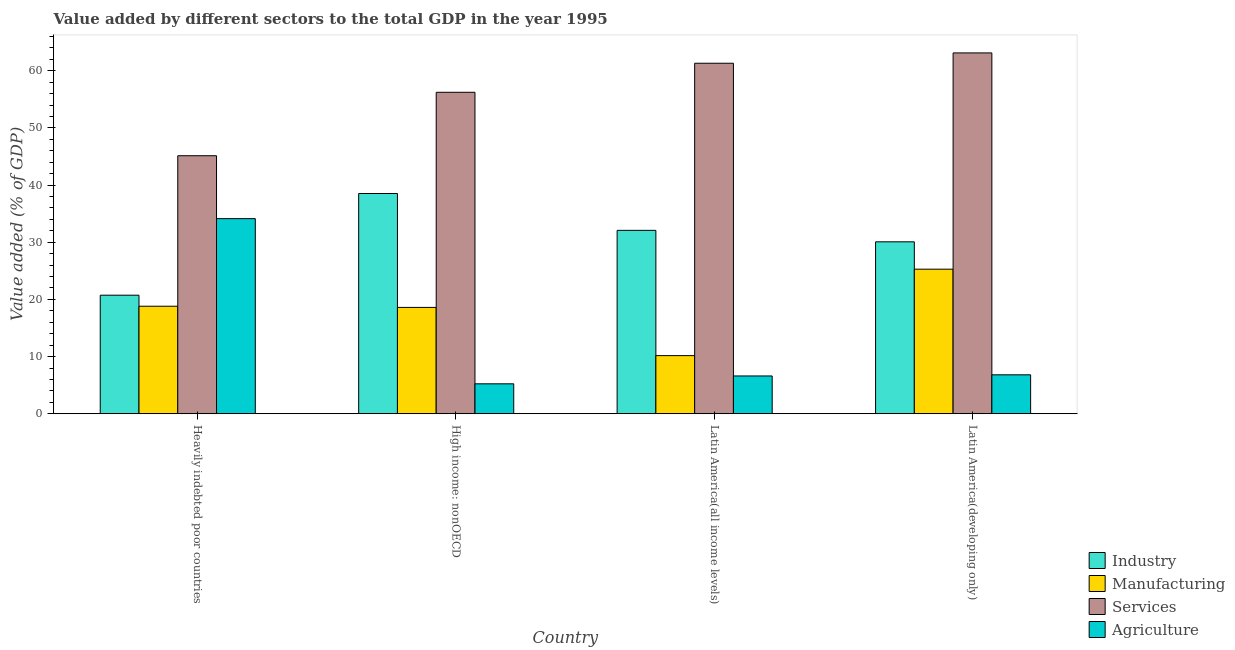How many groups of bars are there?
Provide a succinct answer. 4. Are the number of bars per tick equal to the number of legend labels?
Make the answer very short. Yes. How many bars are there on the 1st tick from the left?
Ensure brevity in your answer.  4. How many bars are there on the 4th tick from the right?
Your response must be concise. 4. What is the label of the 2nd group of bars from the left?
Your answer should be compact. High income: nonOECD. In how many cases, is the number of bars for a given country not equal to the number of legend labels?
Give a very brief answer. 0. What is the value added by manufacturing sector in Latin America(developing only)?
Offer a very short reply. 25.29. Across all countries, what is the maximum value added by services sector?
Offer a very short reply. 63.12. Across all countries, what is the minimum value added by services sector?
Give a very brief answer. 45.13. In which country was the value added by manufacturing sector maximum?
Make the answer very short. Latin America(developing only). In which country was the value added by agricultural sector minimum?
Ensure brevity in your answer.  High income: nonOECD. What is the total value added by manufacturing sector in the graph?
Ensure brevity in your answer.  72.86. What is the difference between the value added by industrial sector in Heavily indebted poor countries and that in Latin America(all income levels)?
Your answer should be very brief. -11.34. What is the difference between the value added by agricultural sector in Latin America(developing only) and the value added by services sector in Heavily indebted poor countries?
Offer a very short reply. -38.33. What is the average value added by services sector per country?
Provide a succinct answer. 56.45. What is the difference between the value added by industrial sector and value added by agricultural sector in Heavily indebted poor countries?
Provide a succinct answer. -13.39. What is the ratio of the value added by industrial sector in High income: nonOECD to that in Latin America(developing only)?
Provide a short and direct response. 1.28. Is the value added by manufacturing sector in Heavily indebted poor countries less than that in Latin America(all income levels)?
Your response must be concise. No. Is the difference between the value added by services sector in High income: nonOECD and Latin America(developing only) greater than the difference between the value added by industrial sector in High income: nonOECD and Latin America(developing only)?
Ensure brevity in your answer.  No. What is the difference between the highest and the second highest value added by services sector?
Offer a terse response. 1.81. What is the difference between the highest and the lowest value added by agricultural sector?
Provide a short and direct response. 28.9. In how many countries, is the value added by agricultural sector greater than the average value added by agricultural sector taken over all countries?
Offer a very short reply. 1. Is the sum of the value added by services sector in Heavily indebted poor countries and High income: nonOECD greater than the maximum value added by manufacturing sector across all countries?
Ensure brevity in your answer.  Yes. What does the 2nd bar from the left in High income: nonOECD represents?
Provide a succinct answer. Manufacturing. What does the 1st bar from the right in High income: nonOECD represents?
Your response must be concise. Agriculture. Are all the bars in the graph horizontal?
Provide a succinct answer. No. How many countries are there in the graph?
Your answer should be very brief. 4. What is the difference between two consecutive major ticks on the Y-axis?
Offer a very short reply. 10. Are the values on the major ticks of Y-axis written in scientific E-notation?
Ensure brevity in your answer.  No. Does the graph contain any zero values?
Your answer should be compact. No. What is the title of the graph?
Give a very brief answer. Value added by different sectors to the total GDP in the year 1995. What is the label or title of the X-axis?
Keep it short and to the point. Country. What is the label or title of the Y-axis?
Keep it short and to the point. Value added (% of GDP). What is the Value added (% of GDP) of Industry in Heavily indebted poor countries?
Your response must be concise. 20.74. What is the Value added (% of GDP) of Manufacturing in Heavily indebted poor countries?
Your response must be concise. 18.81. What is the Value added (% of GDP) in Services in Heavily indebted poor countries?
Offer a very short reply. 45.13. What is the Value added (% of GDP) in Agriculture in Heavily indebted poor countries?
Your response must be concise. 34.13. What is the Value added (% of GDP) in Industry in High income: nonOECD?
Provide a succinct answer. 38.53. What is the Value added (% of GDP) in Manufacturing in High income: nonOECD?
Your answer should be very brief. 18.6. What is the Value added (% of GDP) in Services in High income: nonOECD?
Ensure brevity in your answer.  56.23. What is the Value added (% of GDP) of Agriculture in High income: nonOECD?
Offer a terse response. 5.23. What is the Value added (% of GDP) of Industry in Latin America(all income levels)?
Keep it short and to the point. 32.08. What is the Value added (% of GDP) of Manufacturing in Latin America(all income levels)?
Make the answer very short. 10.17. What is the Value added (% of GDP) in Services in Latin America(all income levels)?
Your answer should be compact. 61.31. What is the Value added (% of GDP) in Agriculture in Latin America(all income levels)?
Provide a succinct answer. 6.61. What is the Value added (% of GDP) of Industry in Latin America(developing only)?
Your answer should be compact. 30.07. What is the Value added (% of GDP) in Manufacturing in Latin America(developing only)?
Your response must be concise. 25.29. What is the Value added (% of GDP) in Services in Latin America(developing only)?
Offer a very short reply. 63.12. What is the Value added (% of GDP) of Agriculture in Latin America(developing only)?
Offer a terse response. 6.81. Across all countries, what is the maximum Value added (% of GDP) in Industry?
Keep it short and to the point. 38.53. Across all countries, what is the maximum Value added (% of GDP) of Manufacturing?
Keep it short and to the point. 25.29. Across all countries, what is the maximum Value added (% of GDP) of Services?
Your response must be concise. 63.12. Across all countries, what is the maximum Value added (% of GDP) of Agriculture?
Your answer should be very brief. 34.13. Across all countries, what is the minimum Value added (% of GDP) of Industry?
Provide a succinct answer. 20.74. Across all countries, what is the minimum Value added (% of GDP) in Manufacturing?
Offer a very short reply. 10.17. Across all countries, what is the minimum Value added (% of GDP) of Services?
Provide a succinct answer. 45.13. Across all countries, what is the minimum Value added (% of GDP) in Agriculture?
Your answer should be very brief. 5.23. What is the total Value added (% of GDP) of Industry in the graph?
Give a very brief answer. 121.42. What is the total Value added (% of GDP) of Manufacturing in the graph?
Make the answer very short. 72.86. What is the total Value added (% of GDP) in Services in the graph?
Keep it short and to the point. 225.8. What is the total Value added (% of GDP) of Agriculture in the graph?
Keep it short and to the point. 52.78. What is the difference between the Value added (% of GDP) of Industry in Heavily indebted poor countries and that in High income: nonOECD?
Your response must be concise. -17.79. What is the difference between the Value added (% of GDP) of Manufacturing in Heavily indebted poor countries and that in High income: nonOECD?
Ensure brevity in your answer.  0.21. What is the difference between the Value added (% of GDP) in Services in Heavily indebted poor countries and that in High income: nonOECD?
Provide a succinct answer. -11.1. What is the difference between the Value added (% of GDP) in Agriculture in Heavily indebted poor countries and that in High income: nonOECD?
Your answer should be compact. 28.9. What is the difference between the Value added (% of GDP) in Industry in Heavily indebted poor countries and that in Latin America(all income levels)?
Your response must be concise. -11.34. What is the difference between the Value added (% of GDP) of Manufacturing in Heavily indebted poor countries and that in Latin America(all income levels)?
Provide a succinct answer. 8.64. What is the difference between the Value added (% of GDP) of Services in Heavily indebted poor countries and that in Latin America(all income levels)?
Your answer should be very brief. -16.18. What is the difference between the Value added (% of GDP) of Agriculture in Heavily indebted poor countries and that in Latin America(all income levels)?
Your response must be concise. 27.52. What is the difference between the Value added (% of GDP) in Industry in Heavily indebted poor countries and that in Latin America(developing only)?
Provide a succinct answer. -9.34. What is the difference between the Value added (% of GDP) of Manufacturing in Heavily indebted poor countries and that in Latin America(developing only)?
Your answer should be very brief. -6.48. What is the difference between the Value added (% of GDP) of Services in Heavily indebted poor countries and that in Latin America(developing only)?
Provide a succinct answer. -17.99. What is the difference between the Value added (% of GDP) of Agriculture in Heavily indebted poor countries and that in Latin America(developing only)?
Ensure brevity in your answer.  27.32. What is the difference between the Value added (% of GDP) of Industry in High income: nonOECD and that in Latin America(all income levels)?
Your answer should be compact. 6.45. What is the difference between the Value added (% of GDP) in Manufacturing in High income: nonOECD and that in Latin America(all income levels)?
Offer a terse response. 8.43. What is the difference between the Value added (% of GDP) in Services in High income: nonOECD and that in Latin America(all income levels)?
Provide a short and direct response. -5.08. What is the difference between the Value added (% of GDP) in Agriculture in High income: nonOECD and that in Latin America(all income levels)?
Keep it short and to the point. -1.37. What is the difference between the Value added (% of GDP) in Industry in High income: nonOECD and that in Latin America(developing only)?
Your answer should be very brief. 8.46. What is the difference between the Value added (% of GDP) of Manufacturing in High income: nonOECD and that in Latin America(developing only)?
Provide a succinct answer. -6.69. What is the difference between the Value added (% of GDP) of Services in High income: nonOECD and that in Latin America(developing only)?
Ensure brevity in your answer.  -6.89. What is the difference between the Value added (% of GDP) of Agriculture in High income: nonOECD and that in Latin America(developing only)?
Give a very brief answer. -1.57. What is the difference between the Value added (% of GDP) in Industry in Latin America(all income levels) and that in Latin America(developing only)?
Your answer should be very brief. 2.01. What is the difference between the Value added (% of GDP) of Manufacturing in Latin America(all income levels) and that in Latin America(developing only)?
Your answer should be very brief. -15.12. What is the difference between the Value added (% of GDP) of Services in Latin America(all income levels) and that in Latin America(developing only)?
Provide a succinct answer. -1.81. What is the difference between the Value added (% of GDP) in Agriculture in Latin America(all income levels) and that in Latin America(developing only)?
Give a very brief answer. -0.2. What is the difference between the Value added (% of GDP) of Industry in Heavily indebted poor countries and the Value added (% of GDP) of Manufacturing in High income: nonOECD?
Provide a short and direct response. 2.14. What is the difference between the Value added (% of GDP) in Industry in Heavily indebted poor countries and the Value added (% of GDP) in Services in High income: nonOECD?
Make the answer very short. -35.49. What is the difference between the Value added (% of GDP) in Industry in Heavily indebted poor countries and the Value added (% of GDP) in Agriculture in High income: nonOECD?
Your answer should be very brief. 15.5. What is the difference between the Value added (% of GDP) of Manufacturing in Heavily indebted poor countries and the Value added (% of GDP) of Services in High income: nonOECD?
Offer a terse response. -37.42. What is the difference between the Value added (% of GDP) in Manufacturing in Heavily indebted poor countries and the Value added (% of GDP) in Agriculture in High income: nonOECD?
Offer a terse response. 13.57. What is the difference between the Value added (% of GDP) in Services in Heavily indebted poor countries and the Value added (% of GDP) in Agriculture in High income: nonOECD?
Keep it short and to the point. 39.9. What is the difference between the Value added (% of GDP) of Industry in Heavily indebted poor countries and the Value added (% of GDP) of Manufacturing in Latin America(all income levels)?
Your answer should be very brief. 10.57. What is the difference between the Value added (% of GDP) in Industry in Heavily indebted poor countries and the Value added (% of GDP) in Services in Latin America(all income levels)?
Provide a short and direct response. -40.58. What is the difference between the Value added (% of GDP) of Industry in Heavily indebted poor countries and the Value added (% of GDP) of Agriculture in Latin America(all income levels)?
Offer a very short reply. 14.13. What is the difference between the Value added (% of GDP) in Manufacturing in Heavily indebted poor countries and the Value added (% of GDP) in Services in Latin America(all income levels)?
Ensure brevity in your answer.  -42.5. What is the difference between the Value added (% of GDP) in Manufacturing in Heavily indebted poor countries and the Value added (% of GDP) in Agriculture in Latin America(all income levels)?
Your response must be concise. 12.2. What is the difference between the Value added (% of GDP) in Services in Heavily indebted poor countries and the Value added (% of GDP) in Agriculture in Latin America(all income levels)?
Your answer should be compact. 38.53. What is the difference between the Value added (% of GDP) in Industry in Heavily indebted poor countries and the Value added (% of GDP) in Manufacturing in Latin America(developing only)?
Your answer should be very brief. -4.55. What is the difference between the Value added (% of GDP) in Industry in Heavily indebted poor countries and the Value added (% of GDP) in Services in Latin America(developing only)?
Offer a terse response. -42.38. What is the difference between the Value added (% of GDP) in Industry in Heavily indebted poor countries and the Value added (% of GDP) in Agriculture in Latin America(developing only)?
Provide a succinct answer. 13.93. What is the difference between the Value added (% of GDP) in Manufacturing in Heavily indebted poor countries and the Value added (% of GDP) in Services in Latin America(developing only)?
Offer a very short reply. -44.31. What is the difference between the Value added (% of GDP) in Manufacturing in Heavily indebted poor countries and the Value added (% of GDP) in Agriculture in Latin America(developing only)?
Provide a succinct answer. 12. What is the difference between the Value added (% of GDP) of Services in Heavily indebted poor countries and the Value added (% of GDP) of Agriculture in Latin America(developing only)?
Give a very brief answer. 38.33. What is the difference between the Value added (% of GDP) in Industry in High income: nonOECD and the Value added (% of GDP) in Manufacturing in Latin America(all income levels)?
Ensure brevity in your answer.  28.36. What is the difference between the Value added (% of GDP) of Industry in High income: nonOECD and the Value added (% of GDP) of Services in Latin America(all income levels)?
Ensure brevity in your answer.  -22.78. What is the difference between the Value added (% of GDP) in Industry in High income: nonOECD and the Value added (% of GDP) in Agriculture in Latin America(all income levels)?
Offer a very short reply. 31.92. What is the difference between the Value added (% of GDP) of Manufacturing in High income: nonOECD and the Value added (% of GDP) of Services in Latin America(all income levels)?
Your response must be concise. -42.71. What is the difference between the Value added (% of GDP) of Manufacturing in High income: nonOECD and the Value added (% of GDP) of Agriculture in Latin America(all income levels)?
Offer a very short reply. 11.99. What is the difference between the Value added (% of GDP) in Services in High income: nonOECD and the Value added (% of GDP) in Agriculture in Latin America(all income levels)?
Make the answer very short. 49.62. What is the difference between the Value added (% of GDP) of Industry in High income: nonOECD and the Value added (% of GDP) of Manufacturing in Latin America(developing only)?
Offer a very short reply. 13.24. What is the difference between the Value added (% of GDP) in Industry in High income: nonOECD and the Value added (% of GDP) in Services in Latin America(developing only)?
Your answer should be compact. -24.59. What is the difference between the Value added (% of GDP) in Industry in High income: nonOECD and the Value added (% of GDP) in Agriculture in Latin America(developing only)?
Make the answer very short. 31.72. What is the difference between the Value added (% of GDP) of Manufacturing in High income: nonOECD and the Value added (% of GDP) of Services in Latin America(developing only)?
Make the answer very short. -44.52. What is the difference between the Value added (% of GDP) in Manufacturing in High income: nonOECD and the Value added (% of GDP) in Agriculture in Latin America(developing only)?
Offer a very short reply. 11.79. What is the difference between the Value added (% of GDP) in Services in High income: nonOECD and the Value added (% of GDP) in Agriculture in Latin America(developing only)?
Offer a terse response. 49.42. What is the difference between the Value added (% of GDP) in Industry in Latin America(all income levels) and the Value added (% of GDP) in Manufacturing in Latin America(developing only)?
Keep it short and to the point. 6.79. What is the difference between the Value added (% of GDP) in Industry in Latin America(all income levels) and the Value added (% of GDP) in Services in Latin America(developing only)?
Your answer should be compact. -31.04. What is the difference between the Value added (% of GDP) of Industry in Latin America(all income levels) and the Value added (% of GDP) of Agriculture in Latin America(developing only)?
Your answer should be compact. 25.27. What is the difference between the Value added (% of GDP) in Manufacturing in Latin America(all income levels) and the Value added (% of GDP) in Services in Latin America(developing only)?
Ensure brevity in your answer.  -52.95. What is the difference between the Value added (% of GDP) in Manufacturing in Latin America(all income levels) and the Value added (% of GDP) in Agriculture in Latin America(developing only)?
Keep it short and to the point. 3.36. What is the difference between the Value added (% of GDP) of Services in Latin America(all income levels) and the Value added (% of GDP) of Agriculture in Latin America(developing only)?
Your answer should be very brief. 54.5. What is the average Value added (% of GDP) in Industry per country?
Offer a very short reply. 30.35. What is the average Value added (% of GDP) of Manufacturing per country?
Your answer should be very brief. 18.22. What is the average Value added (% of GDP) in Services per country?
Provide a succinct answer. 56.45. What is the average Value added (% of GDP) of Agriculture per country?
Your answer should be compact. 13.19. What is the difference between the Value added (% of GDP) of Industry and Value added (% of GDP) of Manufacturing in Heavily indebted poor countries?
Provide a short and direct response. 1.93. What is the difference between the Value added (% of GDP) of Industry and Value added (% of GDP) of Services in Heavily indebted poor countries?
Make the answer very short. -24.4. What is the difference between the Value added (% of GDP) of Industry and Value added (% of GDP) of Agriculture in Heavily indebted poor countries?
Ensure brevity in your answer.  -13.39. What is the difference between the Value added (% of GDP) of Manufacturing and Value added (% of GDP) of Services in Heavily indebted poor countries?
Offer a terse response. -26.33. What is the difference between the Value added (% of GDP) in Manufacturing and Value added (% of GDP) in Agriculture in Heavily indebted poor countries?
Ensure brevity in your answer.  -15.32. What is the difference between the Value added (% of GDP) in Services and Value added (% of GDP) in Agriculture in Heavily indebted poor countries?
Your response must be concise. 11. What is the difference between the Value added (% of GDP) in Industry and Value added (% of GDP) in Manufacturing in High income: nonOECD?
Your response must be concise. 19.93. What is the difference between the Value added (% of GDP) of Industry and Value added (% of GDP) of Services in High income: nonOECD?
Give a very brief answer. -17.7. What is the difference between the Value added (% of GDP) of Industry and Value added (% of GDP) of Agriculture in High income: nonOECD?
Provide a succinct answer. 33.29. What is the difference between the Value added (% of GDP) of Manufacturing and Value added (% of GDP) of Services in High income: nonOECD?
Offer a very short reply. -37.63. What is the difference between the Value added (% of GDP) of Manufacturing and Value added (% of GDP) of Agriculture in High income: nonOECD?
Keep it short and to the point. 13.37. What is the difference between the Value added (% of GDP) in Services and Value added (% of GDP) in Agriculture in High income: nonOECD?
Provide a short and direct response. 51. What is the difference between the Value added (% of GDP) of Industry and Value added (% of GDP) of Manufacturing in Latin America(all income levels)?
Your answer should be very brief. 21.91. What is the difference between the Value added (% of GDP) of Industry and Value added (% of GDP) of Services in Latin America(all income levels)?
Make the answer very short. -29.23. What is the difference between the Value added (% of GDP) of Industry and Value added (% of GDP) of Agriculture in Latin America(all income levels)?
Your response must be concise. 25.47. What is the difference between the Value added (% of GDP) of Manufacturing and Value added (% of GDP) of Services in Latin America(all income levels)?
Keep it short and to the point. -51.14. What is the difference between the Value added (% of GDP) of Manufacturing and Value added (% of GDP) of Agriculture in Latin America(all income levels)?
Your answer should be compact. 3.56. What is the difference between the Value added (% of GDP) in Services and Value added (% of GDP) in Agriculture in Latin America(all income levels)?
Give a very brief answer. 54.7. What is the difference between the Value added (% of GDP) in Industry and Value added (% of GDP) in Manufacturing in Latin America(developing only)?
Your answer should be compact. 4.79. What is the difference between the Value added (% of GDP) of Industry and Value added (% of GDP) of Services in Latin America(developing only)?
Give a very brief answer. -33.05. What is the difference between the Value added (% of GDP) of Industry and Value added (% of GDP) of Agriculture in Latin America(developing only)?
Provide a short and direct response. 23.26. What is the difference between the Value added (% of GDP) in Manufacturing and Value added (% of GDP) in Services in Latin America(developing only)?
Your answer should be compact. -37.83. What is the difference between the Value added (% of GDP) of Manufacturing and Value added (% of GDP) of Agriculture in Latin America(developing only)?
Your response must be concise. 18.48. What is the difference between the Value added (% of GDP) of Services and Value added (% of GDP) of Agriculture in Latin America(developing only)?
Your response must be concise. 56.31. What is the ratio of the Value added (% of GDP) of Industry in Heavily indebted poor countries to that in High income: nonOECD?
Give a very brief answer. 0.54. What is the ratio of the Value added (% of GDP) in Manufacturing in Heavily indebted poor countries to that in High income: nonOECD?
Make the answer very short. 1.01. What is the ratio of the Value added (% of GDP) in Services in Heavily indebted poor countries to that in High income: nonOECD?
Give a very brief answer. 0.8. What is the ratio of the Value added (% of GDP) in Agriculture in Heavily indebted poor countries to that in High income: nonOECD?
Offer a very short reply. 6.52. What is the ratio of the Value added (% of GDP) of Industry in Heavily indebted poor countries to that in Latin America(all income levels)?
Your answer should be very brief. 0.65. What is the ratio of the Value added (% of GDP) in Manufacturing in Heavily indebted poor countries to that in Latin America(all income levels)?
Provide a short and direct response. 1.85. What is the ratio of the Value added (% of GDP) in Services in Heavily indebted poor countries to that in Latin America(all income levels)?
Make the answer very short. 0.74. What is the ratio of the Value added (% of GDP) in Agriculture in Heavily indebted poor countries to that in Latin America(all income levels)?
Keep it short and to the point. 5.17. What is the ratio of the Value added (% of GDP) in Industry in Heavily indebted poor countries to that in Latin America(developing only)?
Give a very brief answer. 0.69. What is the ratio of the Value added (% of GDP) in Manufacturing in Heavily indebted poor countries to that in Latin America(developing only)?
Offer a very short reply. 0.74. What is the ratio of the Value added (% of GDP) of Services in Heavily indebted poor countries to that in Latin America(developing only)?
Your response must be concise. 0.72. What is the ratio of the Value added (% of GDP) of Agriculture in Heavily indebted poor countries to that in Latin America(developing only)?
Provide a short and direct response. 5.01. What is the ratio of the Value added (% of GDP) of Industry in High income: nonOECD to that in Latin America(all income levels)?
Keep it short and to the point. 1.2. What is the ratio of the Value added (% of GDP) of Manufacturing in High income: nonOECD to that in Latin America(all income levels)?
Your response must be concise. 1.83. What is the ratio of the Value added (% of GDP) of Services in High income: nonOECD to that in Latin America(all income levels)?
Your response must be concise. 0.92. What is the ratio of the Value added (% of GDP) in Agriculture in High income: nonOECD to that in Latin America(all income levels)?
Ensure brevity in your answer.  0.79. What is the ratio of the Value added (% of GDP) of Industry in High income: nonOECD to that in Latin America(developing only)?
Offer a terse response. 1.28. What is the ratio of the Value added (% of GDP) in Manufacturing in High income: nonOECD to that in Latin America(developing only)?
Your response must be concise. 0.74. What is the ratio of the Value added (% of GDP) of Services in High income: nonOECD to that in Latin America(developing only)?
Offer a very short reply. 0.89. What is the ratio of the Value added (% of GDP) of Agriculture in High income: nonOECD to that in Latin America(developing only)?
Provide a succinct answer. 0.77. What is the ratio of the Value added (% of GDP) of Industry in Latin America(all income levels) to that in Latin America(developing only)?
Your response must be concise. 1.07. What is the ratio of the Value added (% of GDP) of Manufacturing in Latin America(all income levels) to that in Latin America(developing only)?
Provide a short and direct response. 0.4. What is the ratio of the Value added (% of GDP) in Services in Latin America(all income levels) to that in Latin America(developing only)?
Ensure brevity in your answer.  0.97. What is the ratio of the Value added (% of GDP) in Agriculture in Latin America(all income levels) to that in Latin America(developing only)?
Make the answer very short. 0.97. What is the difference between the highest and the second highest Value added (% of GDP) of Industry?
Offer a very short reply. 6.45. What is the difference between the highest and the second highest Value added (% of GDP) of Manufacturing?
Your response must be concise. 6.48. What is the difference between the highest and the second highest Value added (% of GDP) in Services?
Your response must be concise. 1.81. What is the difference between the highest and the second highest Value added (% of GDP) in Agriculture?
Offer a terse response. 27.32. What is the difference between the highest and the lowest Value added (% of GDP) of Industry?
Make the answer very short. 17.79. What is the difference between the highest and the lowest Value added (% of GDP) of Manufacturing?
Provide a short and direct response. 15.12. What is the difference between the highest and the lowest Value added (% of GDP) of Services?
Give a very brief answer. 17.99. What is the difference between the highest and the lowest Value added (% of GDP) of Agriculture?
Give a very brief answer. 28.9. 